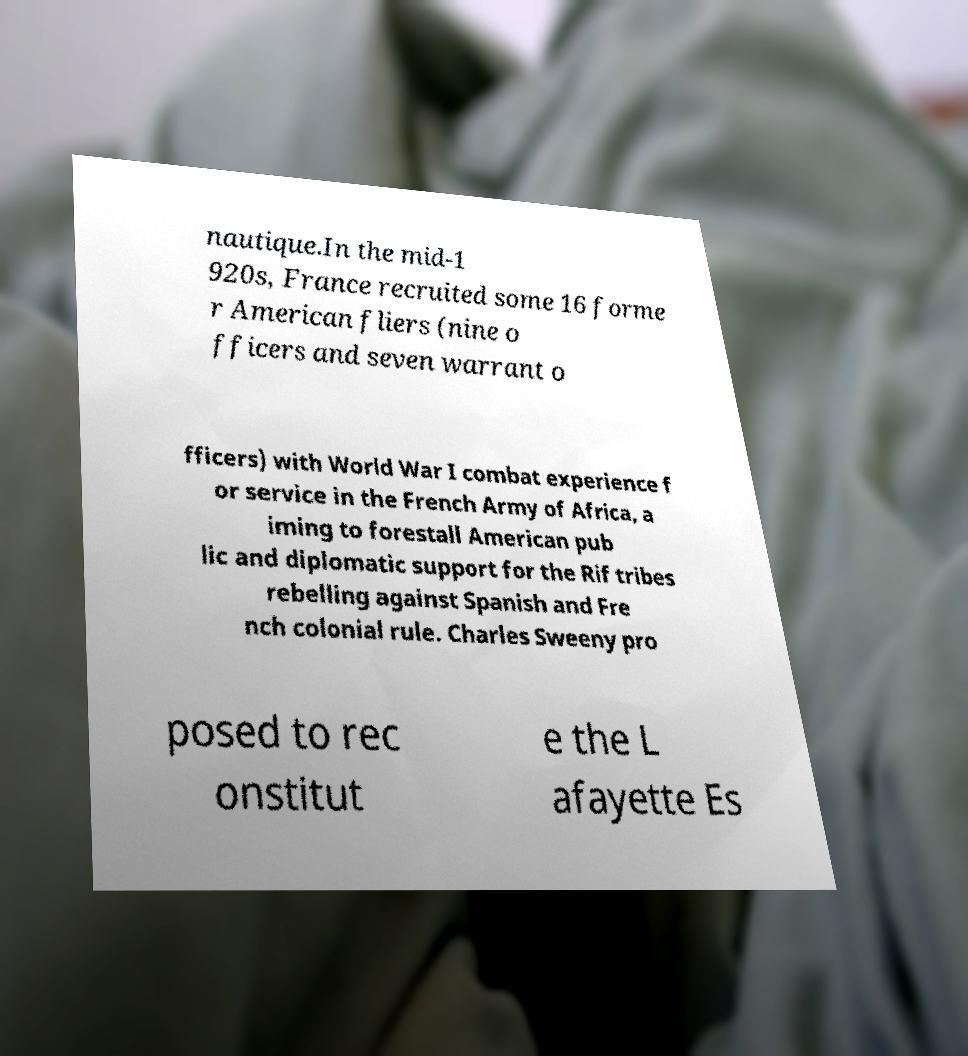I need the written content from this picture converted into text. Can you do that? nautique.In the mid-1 920s, France recruited some 16 forme r American fliers (nine o fficers and seven warrant o fficers) with World War I combat experience f or service in the French Army of Africa, a iming to forestall American pub lic and diplomatic support for the Rif tribes rebelling against Spanish and Fre nch colonial rule. Charles Sweeny pro posed to rec onstitut e the L afayette Es 